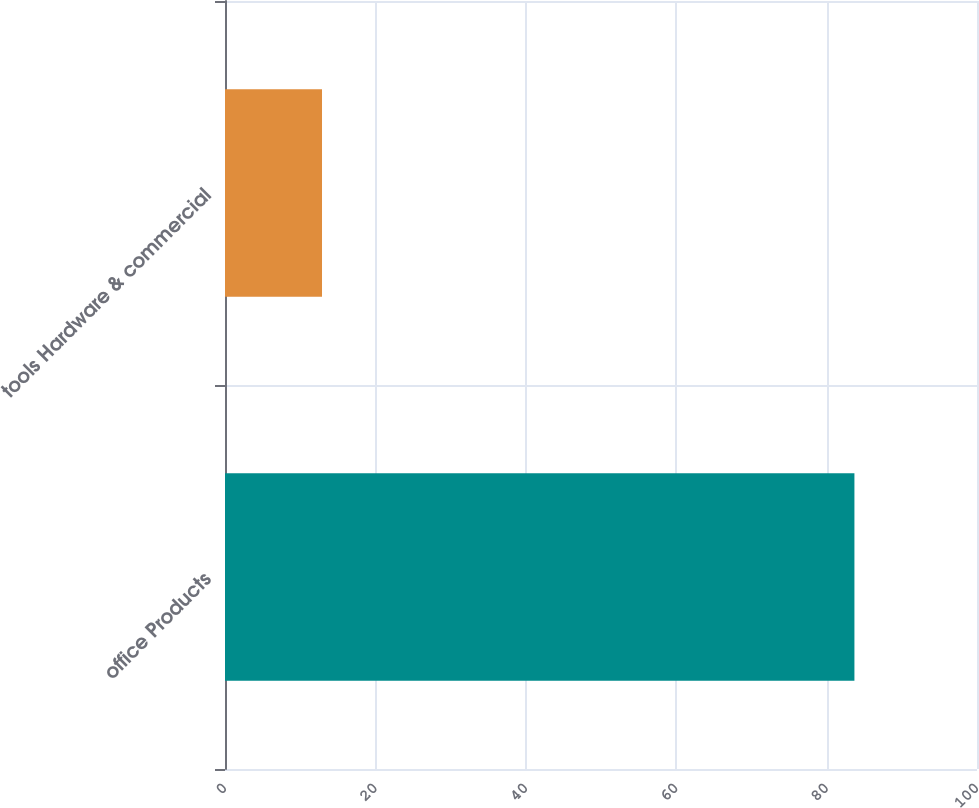Convert chart. <chart><loc_0><loc_0><loc_500><loc_500><bar_chart><fcel>office Products<fcel>tools Hardware & commercial<nl><fcel>83.7<fcel>12.9<nl></chart> 